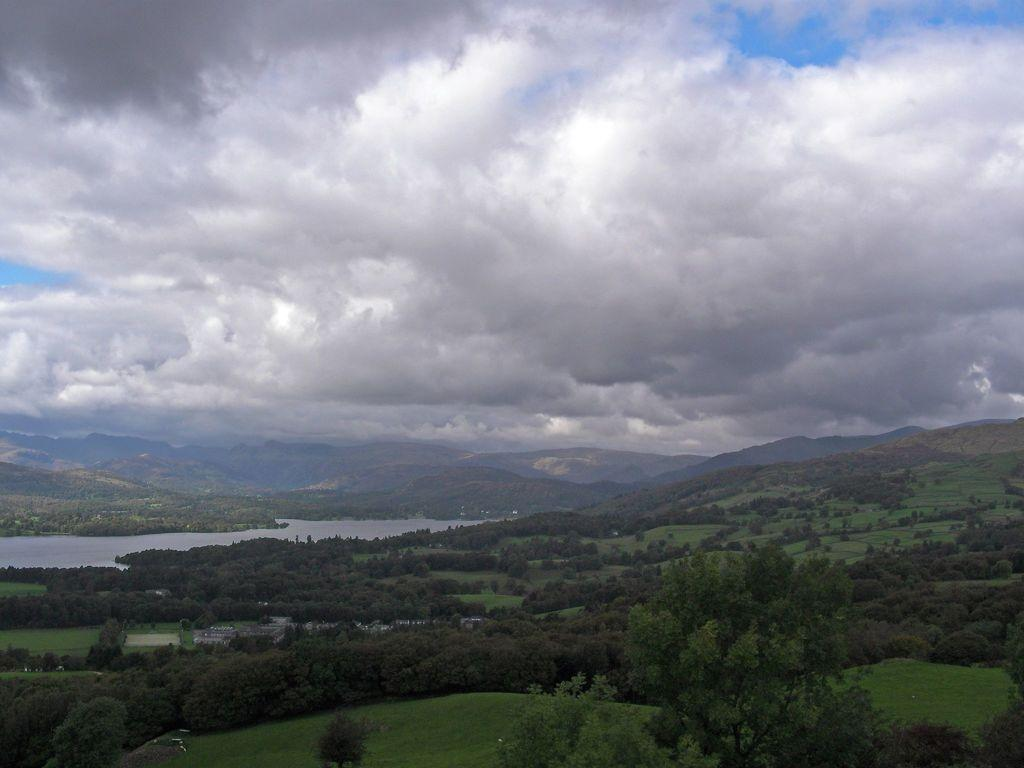What type of natural elements can be seen in the image? There are trees and hills visible in the image. What type of man-made structures are present in the image? There are houses in the image. What is the water feature in the image? There is water visible in the image. What is visible in the sky at the top of the image? There are clouds in the sky at the top of the image. What type of ball is being used for trade in the image? There is no ball or trade activity present in the image. What type of use can be seen for the clouds in the image? The clouds are not being used for any specific purpose in the image; they are simply a natural atmospheric phenomenon. 